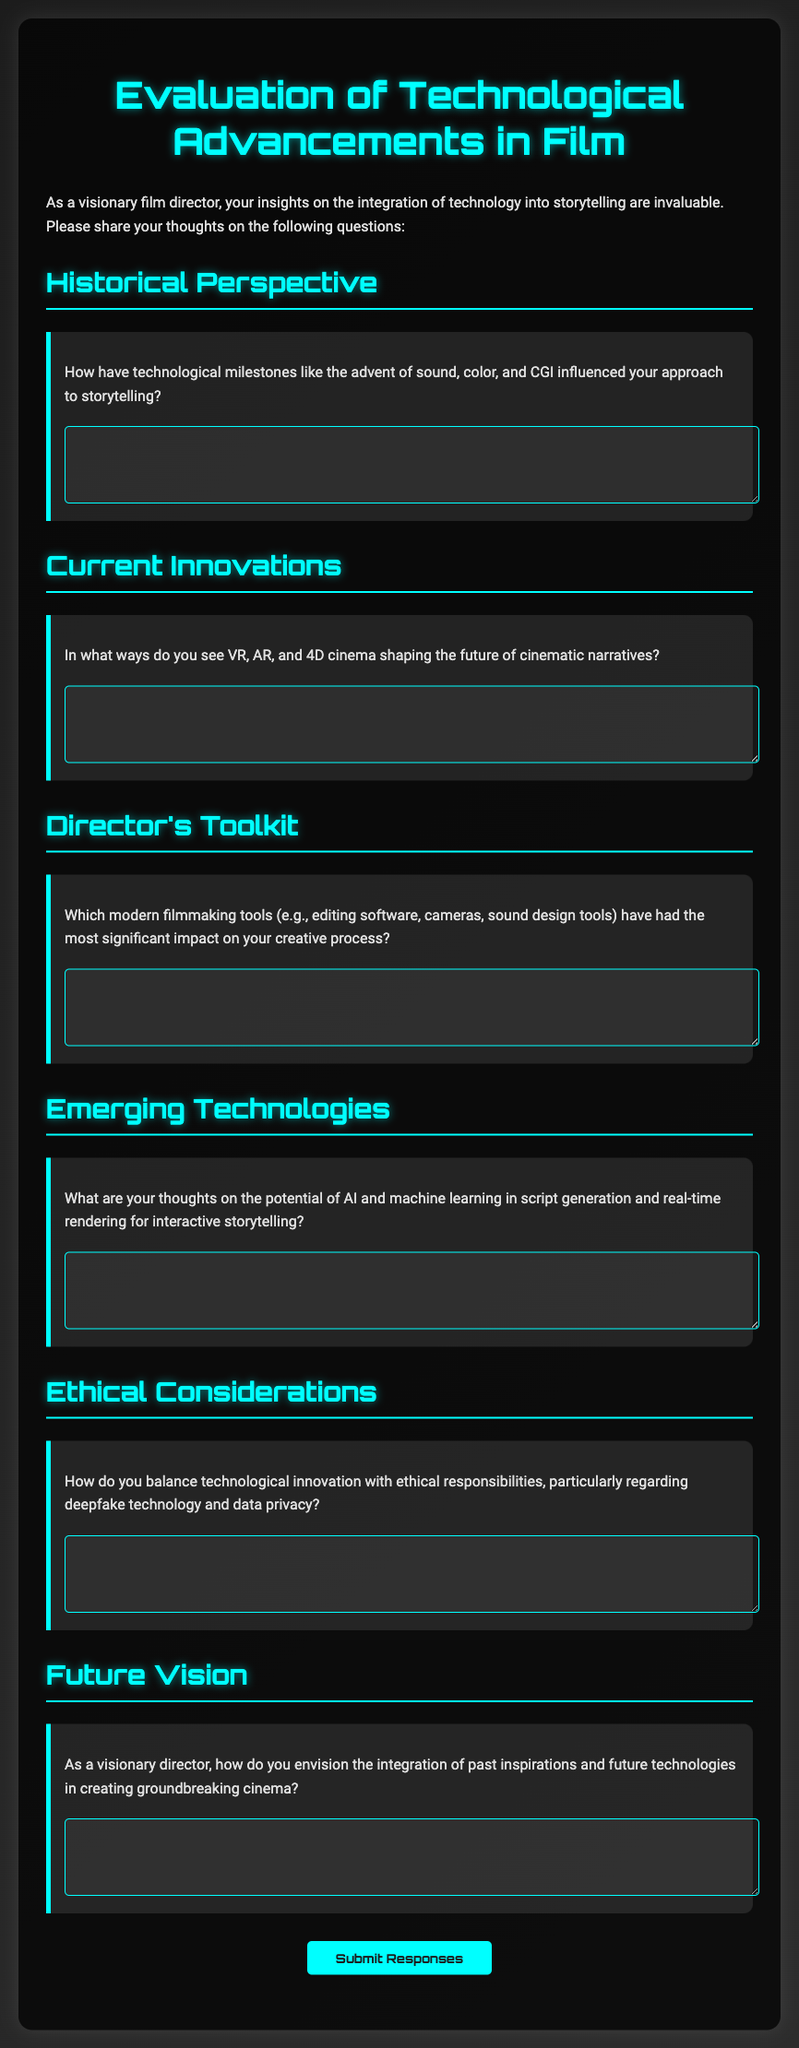What is the title of the document? The title can be found at the top of the rendered document and is a prominent element in the header.
Answer: Evaluation of Technological Advancements in Film: A Director's Perspective What color is the background of the document? The background is described in the styles of the document, featuring a gradient.
Answer: Linear gradient from dark gray to light gray What is the main subject addressed in the questionnaire? The main subject is mentioned in the introduction paragraph, focusing on the director's insights.
Answer: Technological advancements in film and storytelling How many main sections are there in the document? The document is organized into distinct sections, each denoted by headers.
Answer: Six sections Which modern tools does the questionnaire inquire about? The tools mentioned in the document are specifically related to filmmaking and creativity.
Answer: Editing software, cameras, sound design tools What is the purpose of the textarea elements in the document? The text areas are designed for the respondents to provide their insights and responses to each question.
Answer: To collect responses from directors How does the document ask participants to visualize the integration of technology? The document prompts for visionary thinking regarding the fusion of inspirations and future innovations.
Answer: As a combination of past inspirations and future technologies What is the action that the button initiates in the document? The button is clearly labeled, indicating its function upon being clicked.
Answer: Submit Responses 